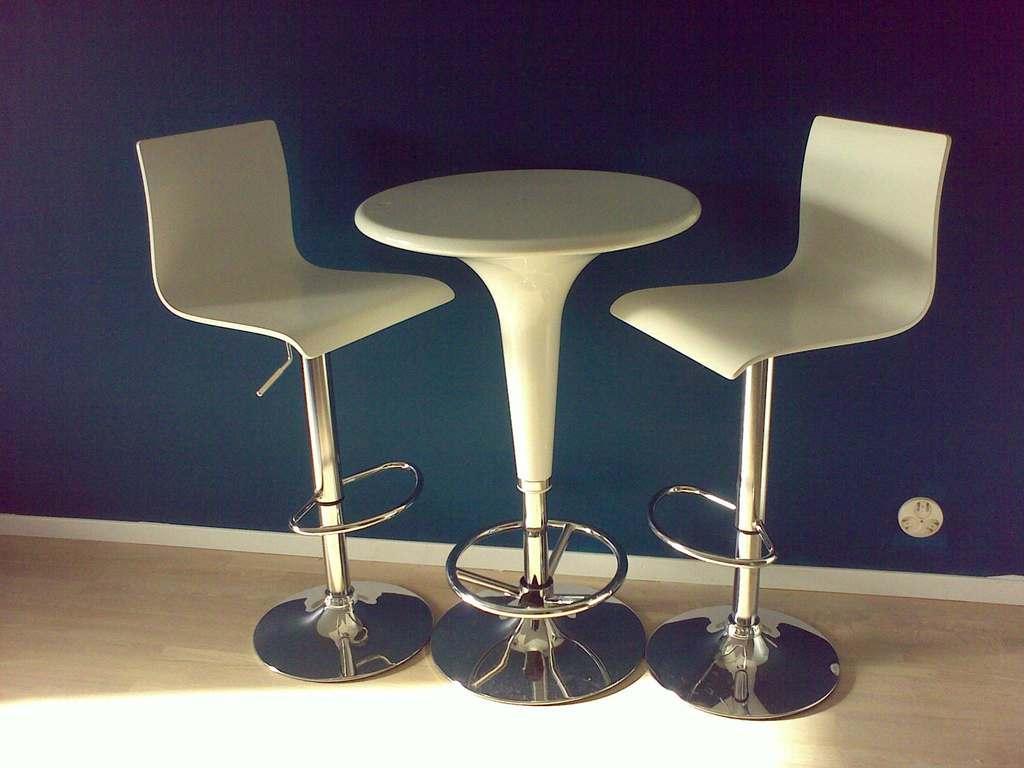How would you summarize this image in a sentence or two? In this image, we can see a few chairs and a table. We can see the ground and the wall with an object. 